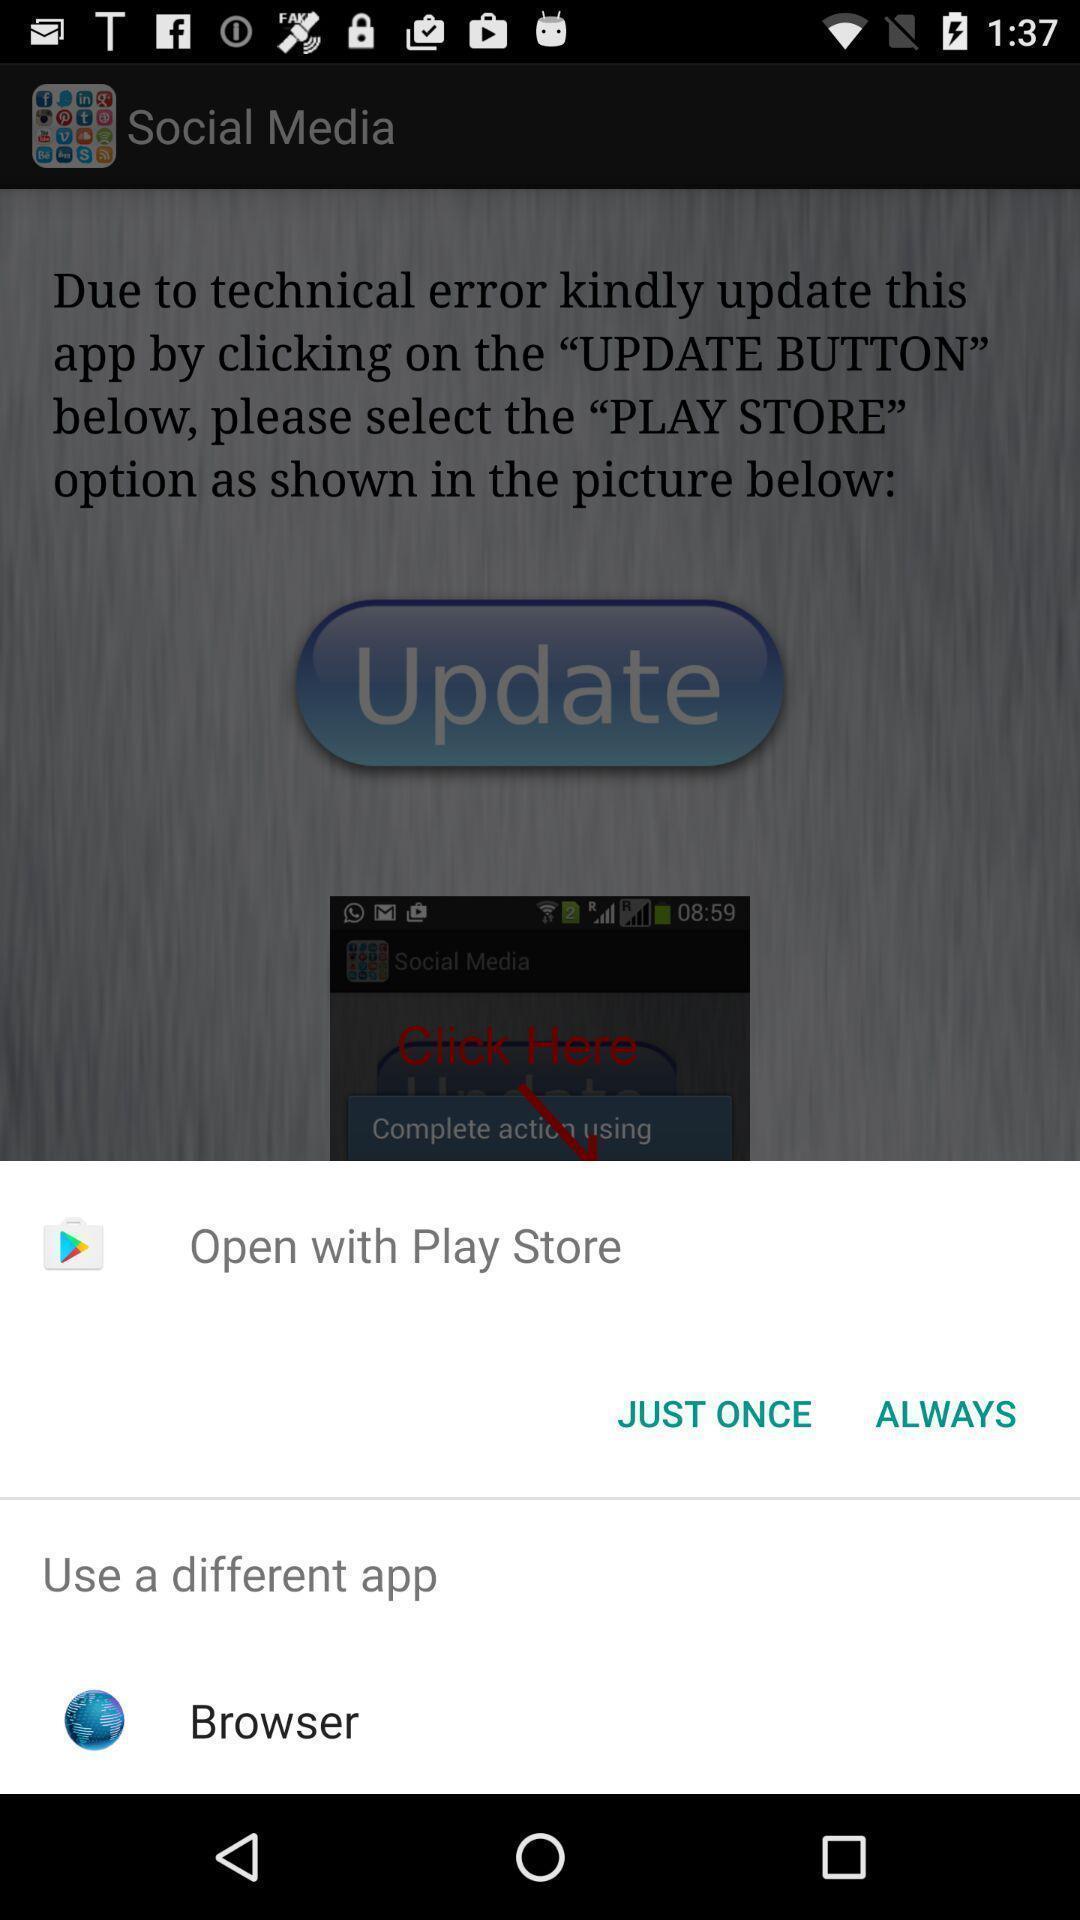What is the overall content of this screenshot? Pop-displaying the apps to open. 